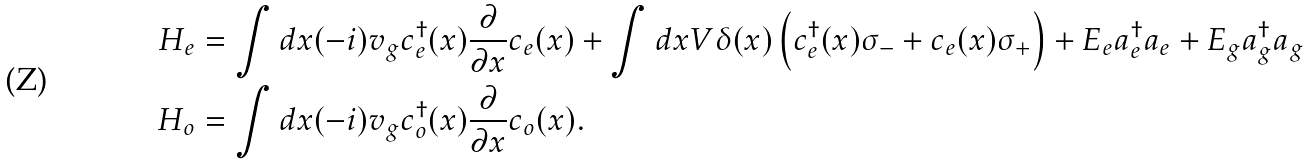<formula> <loc_0><loc_0><loc_500><loc_500>H _ { e } & = \int d x ( - i ) v _ { g } c _ { e } ^ { \dagger } ( x ) \frac { \partial } { \partial x } c _ { e } ( x ) + \int d x V \delta ( x ) \left ( c ^ { \dagger } _ { e } ( x ) \sigma _ { - } + c _ { e } ( x ) \sigma _ { + } \right ) + E _ { e } a ^ { \dagger } _ { e } a _ { e } + E _ { g } a ^ { \dagger } _ { g } a _ { g } \\ H _ { o } & = \int d x ( - i ) v _ { g } c _ { o } ^ { \dagger } ( x ) \frac { \partial } { \partial x } c _ { o } ( x ) .</formula> 